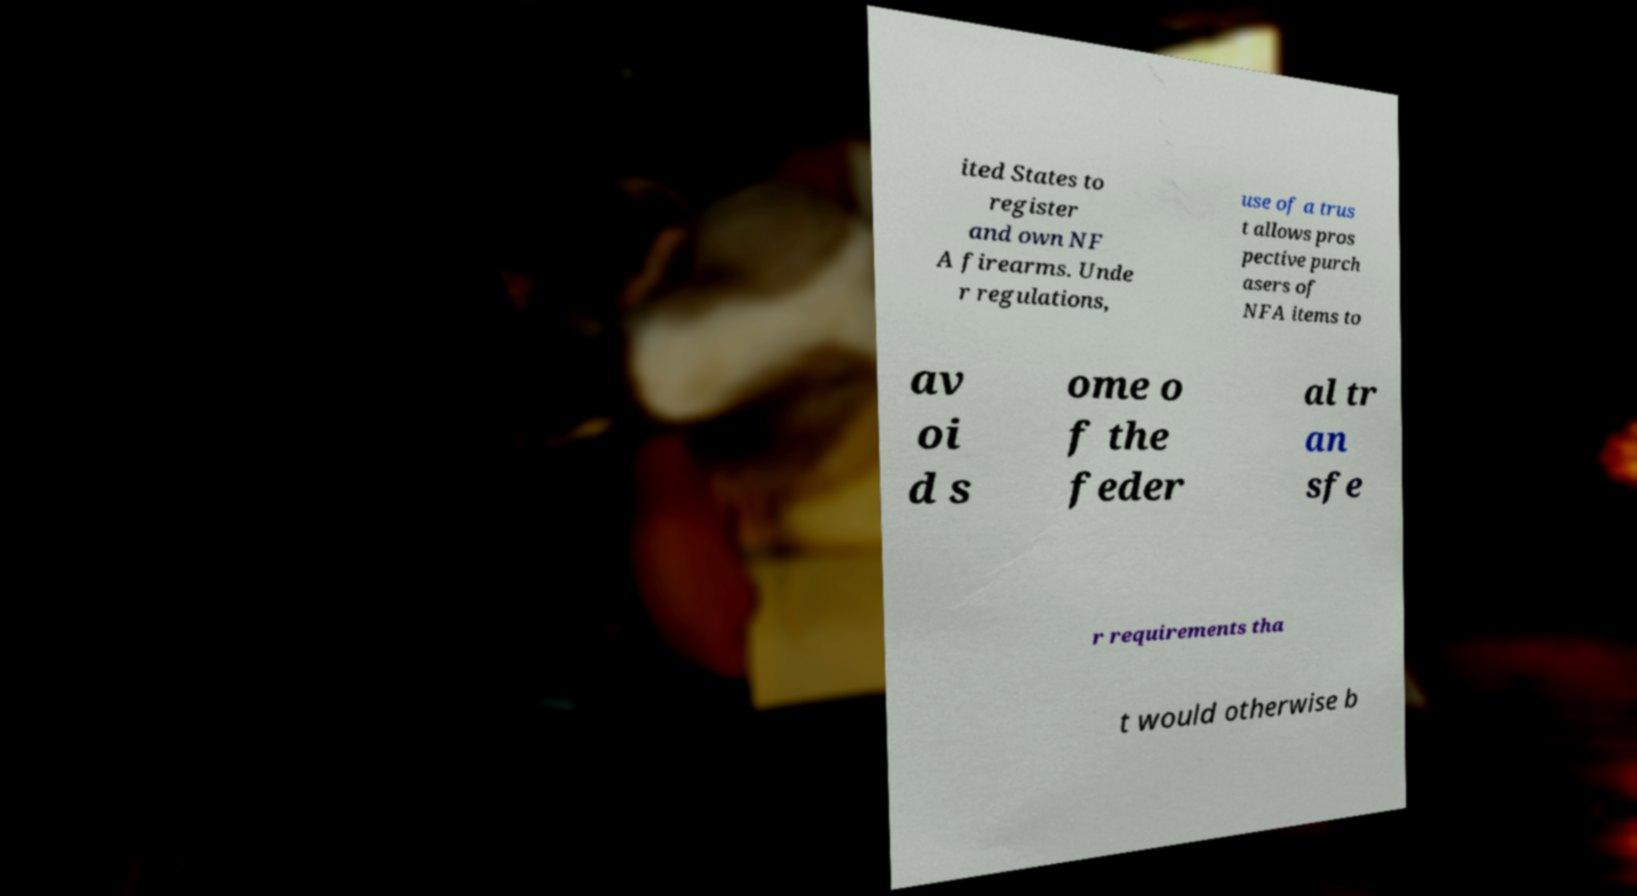Could you assist in decoding the text presented in this image and type it out clearly? ited States to register and own NF A firearms. Unde r regulations, use of a trus t allows pros pective purch asers of NFA items to av oi d s ome o f the feder al tr an sfe r requirements tha t would otherwise b 